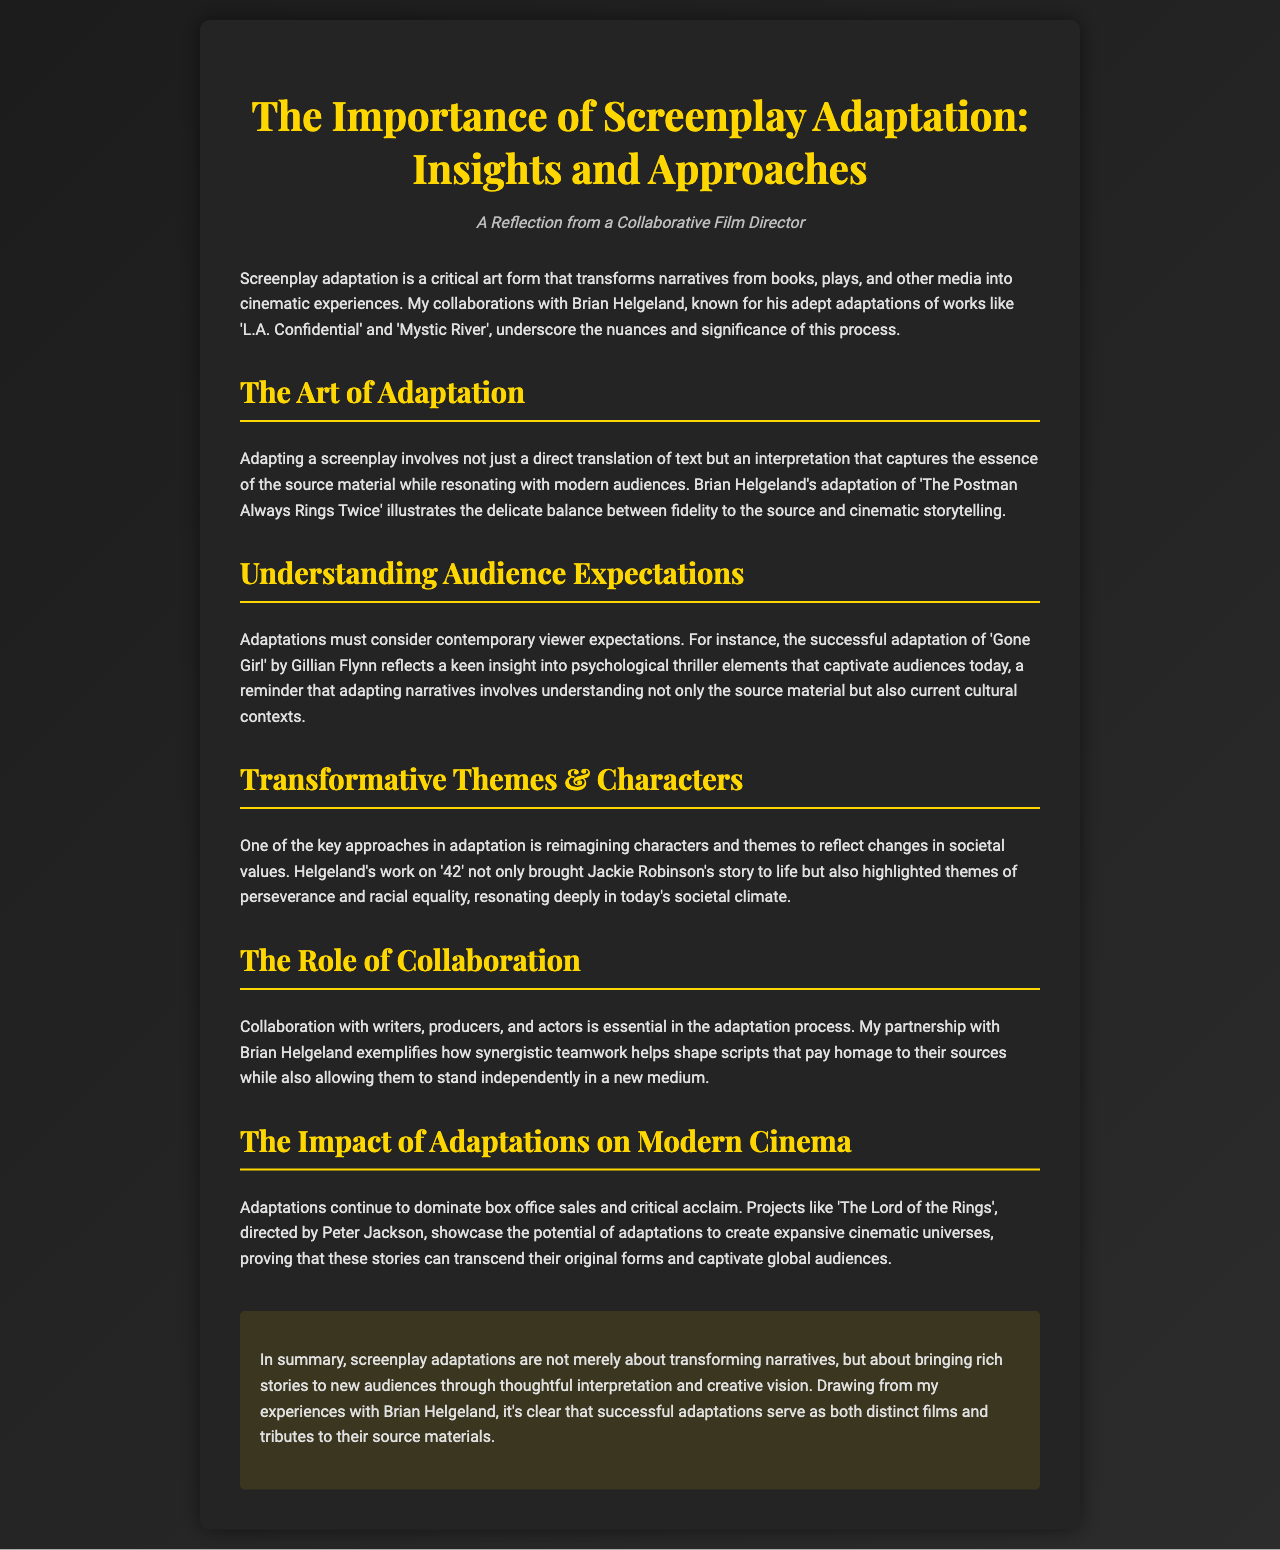what is the title of the brochure? The title is presented prominently at the top of the document.
Answer: The Importance of Screenplay Adaptation: Insights and Approaches who is mentioned as a notable adapter in the brochure? The brochure highlights a specific individual's work in screenplay adaptations.
Answer: Brian Helgeland what is one example of a film mentioned as an adaptation? The text references successful adaptations to illustrate points made throughout the document.
Answer: Gone Girl which theme is highlighted in Helgeland's adaptation of '42'? The brochure discusses transformative themes in adaptation, focusing on a specific work.
Answer: Racial equality how does the brochure describe the impact of adaptations on modern cinema? The document mentions the significance of adaptations in current movie culture.
Answer: Dominates box office sales what is a key aspect of the adaptation process mentioned in the brochure? The text outlines various approaches and considerations in screenplay adaptation.
Answer: Collaboration 